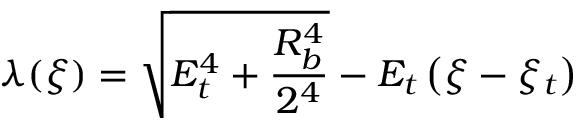Convert formula to latex. <formula><loc_0><loc_0><loc_500><loc_500>\lambda ( \xi ) = \sqrt { E _ { t } ^ { 4 } + \frac { R _ { b } ^ { 4 } } { 2 ^ { 4 } } } - E _ { t } \left ( \xi - \xi _ { t } \right )</formula> 